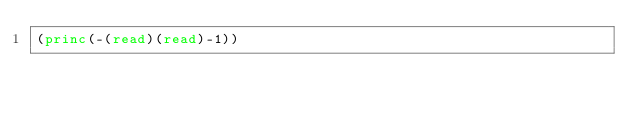<code> <loc_0><loc_0><loc_500><loc_500><_Lisp_>(princ(-(read)(read)-1))</code> 